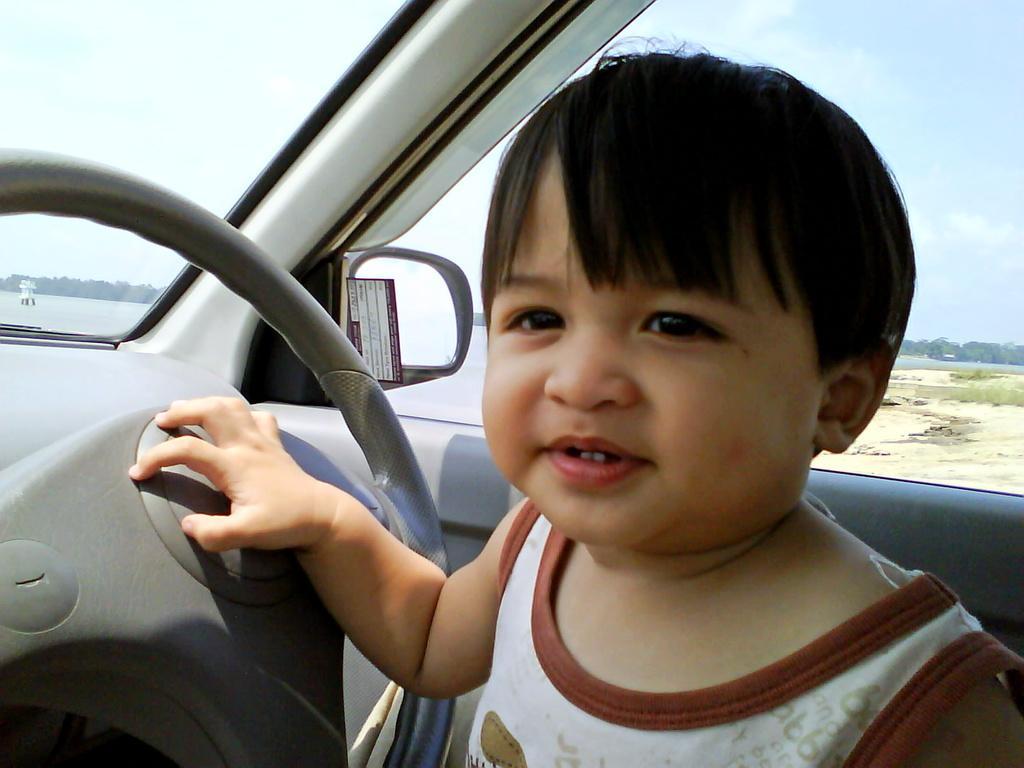In one or two sentences, can you explain what this image depicts? In this picture i could see a kid holding a steering, it seems like he is sitting in the car. In the background i could see a cloudy sky. 